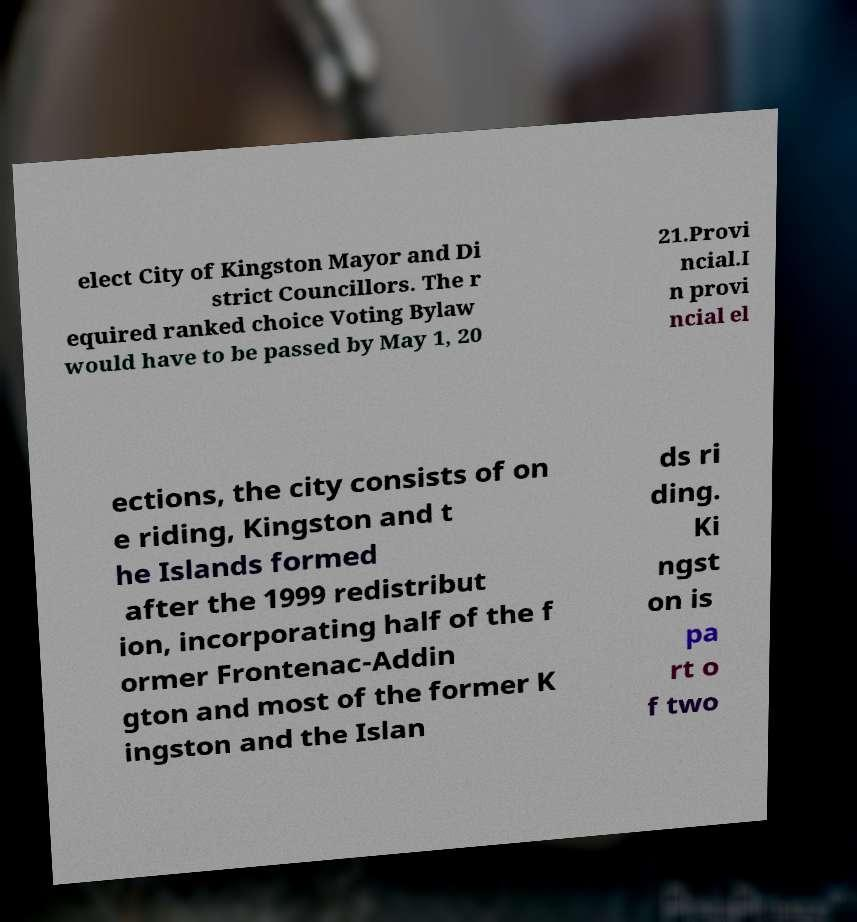Can you accurately transcribe the text from the provided image for me? elect City of Kingston Mayor and Di strict Councillors. The r equired ranked choice Voting Bylaw would have to be passed by May 1, 20 21.Provi ncial.I n provi ncial el ections, the city consists of on e riding, Kingston and t he Islands formed after the 1999 redistribut ion, incorporating half of the f ormer Frontenac-Addin gton and most of the former K ingston and the Islan ds ri ding. Ki ngst on is pa rt o f two 